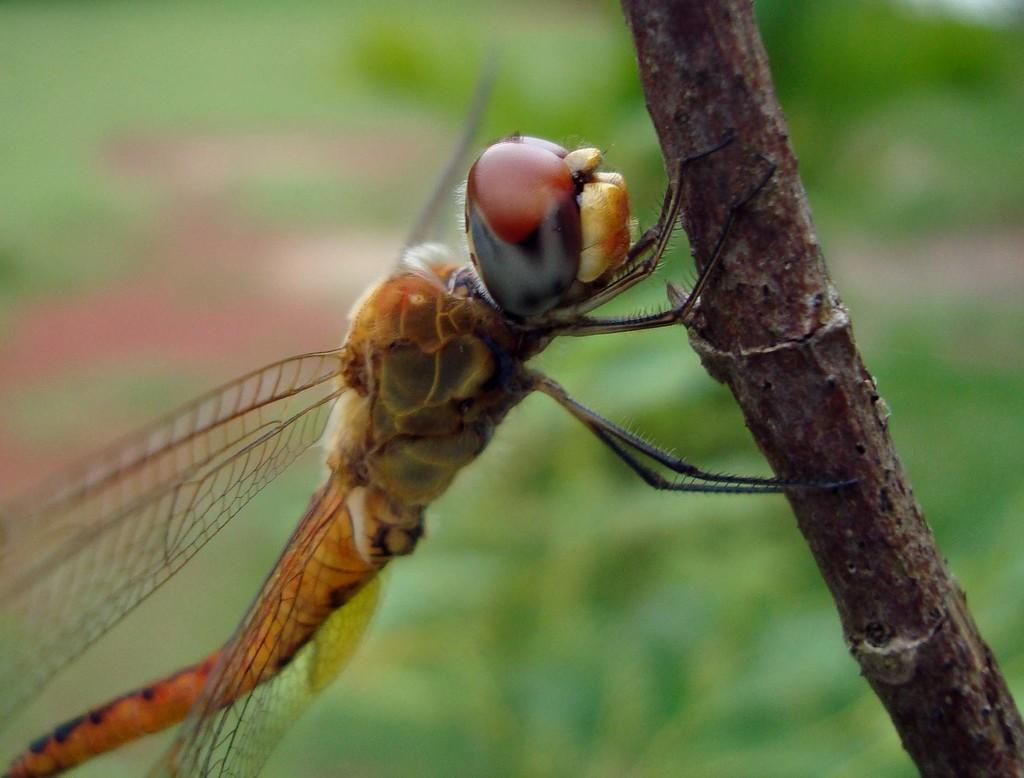What type of insect is present in the image? There is a house fly in the image. Where is the house fly located in the image? The house fly is on the branch of a tree. What type of basin is visible in the image? There is no basin present in the image; it features a house fly on a tree branch. 